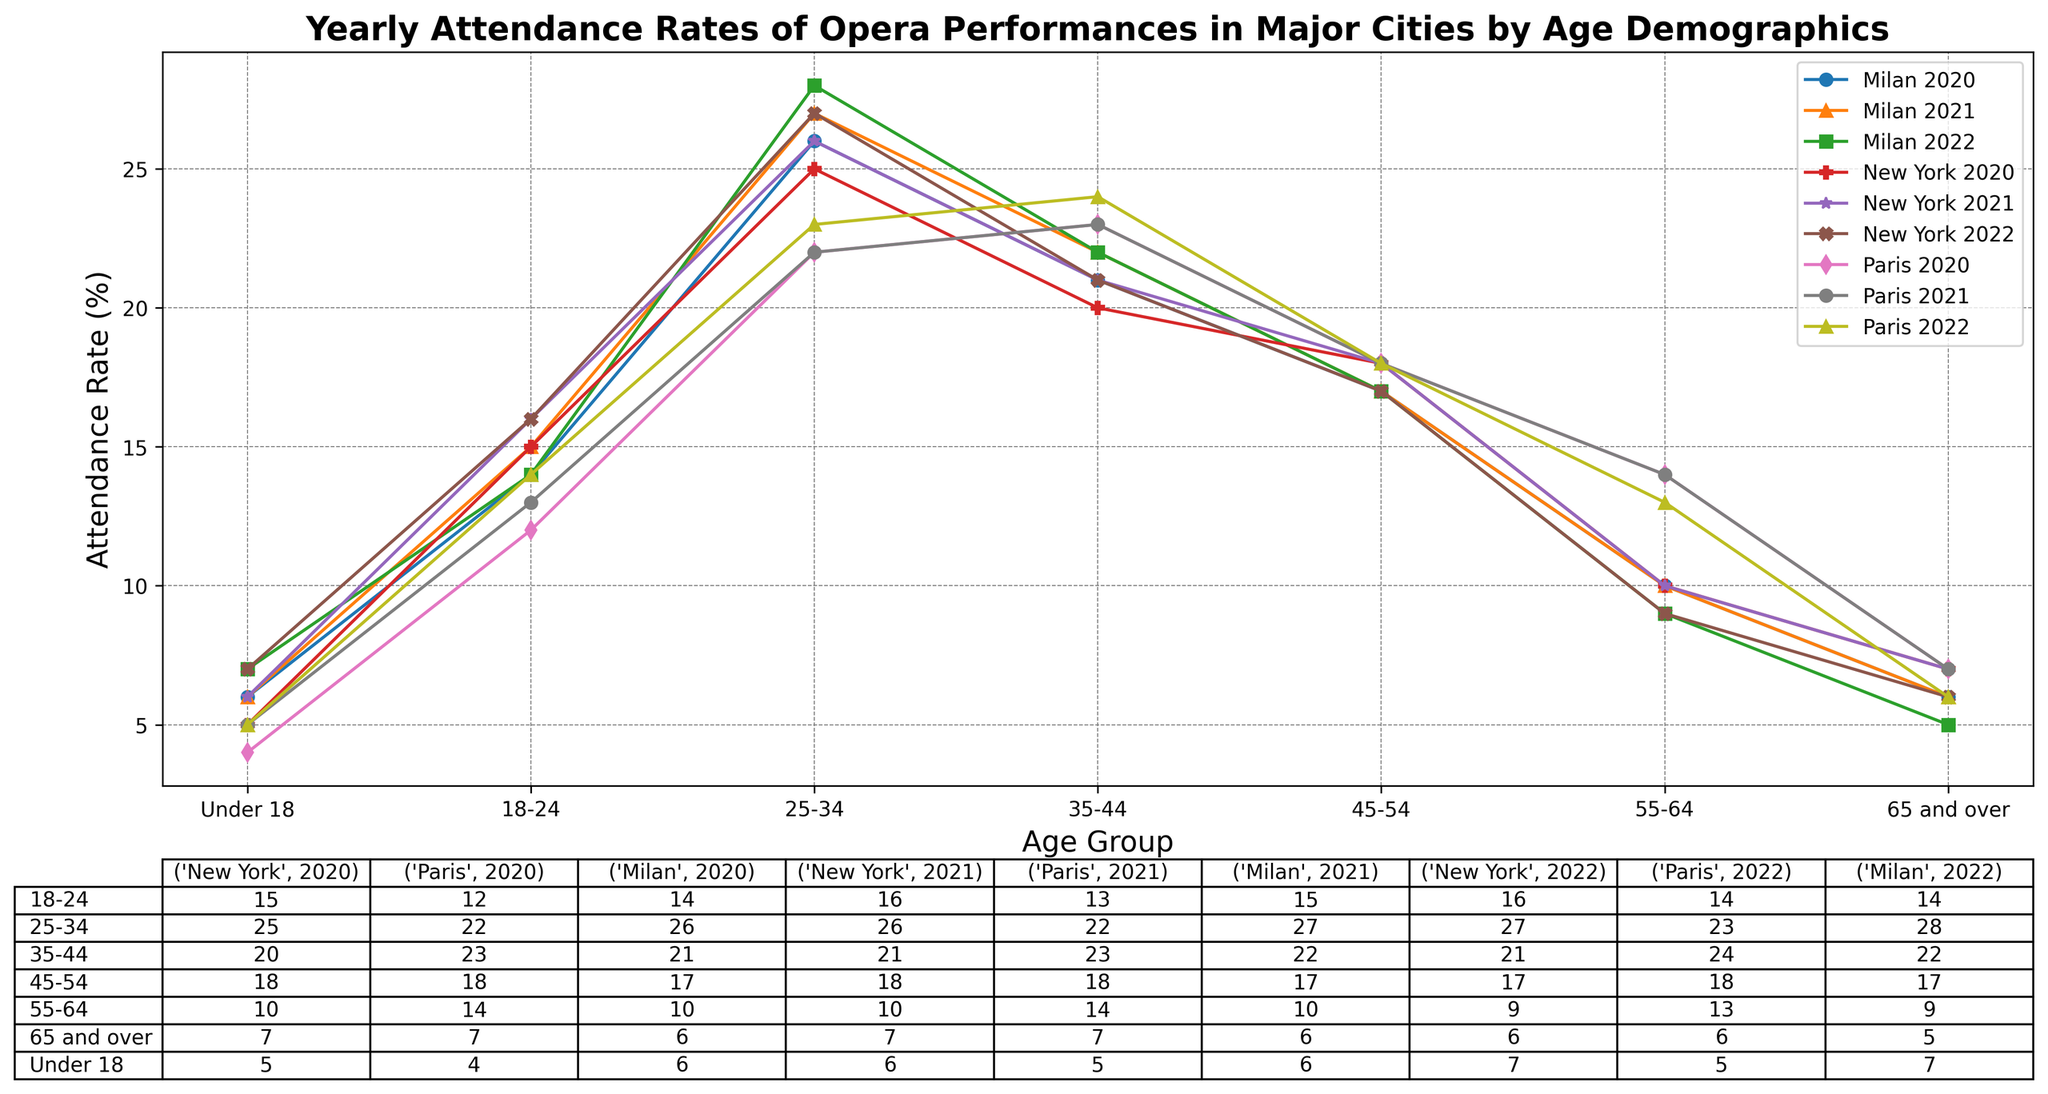What's the attendance rate for the age group 25-34 in Milan in 2021? Locate the corresponding data point on the plot and/or table for Milan (2021) under age group 25-34. The attendance rate is shown as 27%.
Answer: 27% Which city had the highest attendance rate for the age group 18-24 in 2022? Compare the attendance rate for the age group 18-24 in 2022 across all cities in the plot and/or table. The city with the highest rate is Paris with 14%.
Answer: Paris How did the attendance rate for the age group 55-64 in New York change from 2020 to 2022? Look at the trend in the plot and/or table for the age group 55-64 in New York from 2020 to 2022. The rate decreased from 10% in 2020 to 9% in 2022.
Answer: Decreased Which age group had the least variation in attendance rates across the three cities in 2020? Calculate the range (difference between the maximum and minimum rates) for each age group in 2020 across the three cities using the plot and/or table. The age group with the smallest range (1%) is '65 and over' (6%, 7%, 7%).
Answer: 65 and over What is the average attendance rate across all cities for the age group 35-44 in 2020? Extract the attendance rates for this age group (35-44) in 2020 for each city from the plot and/or table (New York: 20%, Paris: 23%, Milan: 21%). Sum them up (20 + 23 + 21 = 64) and divide by the number of cities (3). The average rate is 64/3 = 21.33%.
Answer: 21.33% Which city saw the highest increase in overall attendance rate from 2020 to 2022? Add up the attendance rates for all age groups for each city in 2020 and 2022 using the plot and/or table to find the overall rates. Compare the increases. Milan saw the highest increase (from 100% in 2020 to 111% in 2022).
Answer: Milan How does the attendance rate trend for the age group 'Under 18' compare between New York and Milan from 2020 to 2022? Analyze and compare the plot lines for the age group 'Under 18' in New York and Milan for the years 2020, 2021, and 2022. Both cities show a similar increasing trend from 2020 to 2022.
Answer: Similar increasing trend Which age group consistently had the lowest attendance rate in all cities across all years? Identify the lowest attendance rate age group in each city for each year from the plot and/or table. '65 and over' consistently had the lowest rate across all cities and years.
Answer: 65 and over What was the total attendance rate for the age group 45-54 across all three cities in 2021? Sum the attendance rates for the age group 45-54 in New York (18%), Paris (18%), and Milan (17%) in 2021 using the plot and/or table. The total is 18 + 18 + 17 = 53%.
Answer: 53% 